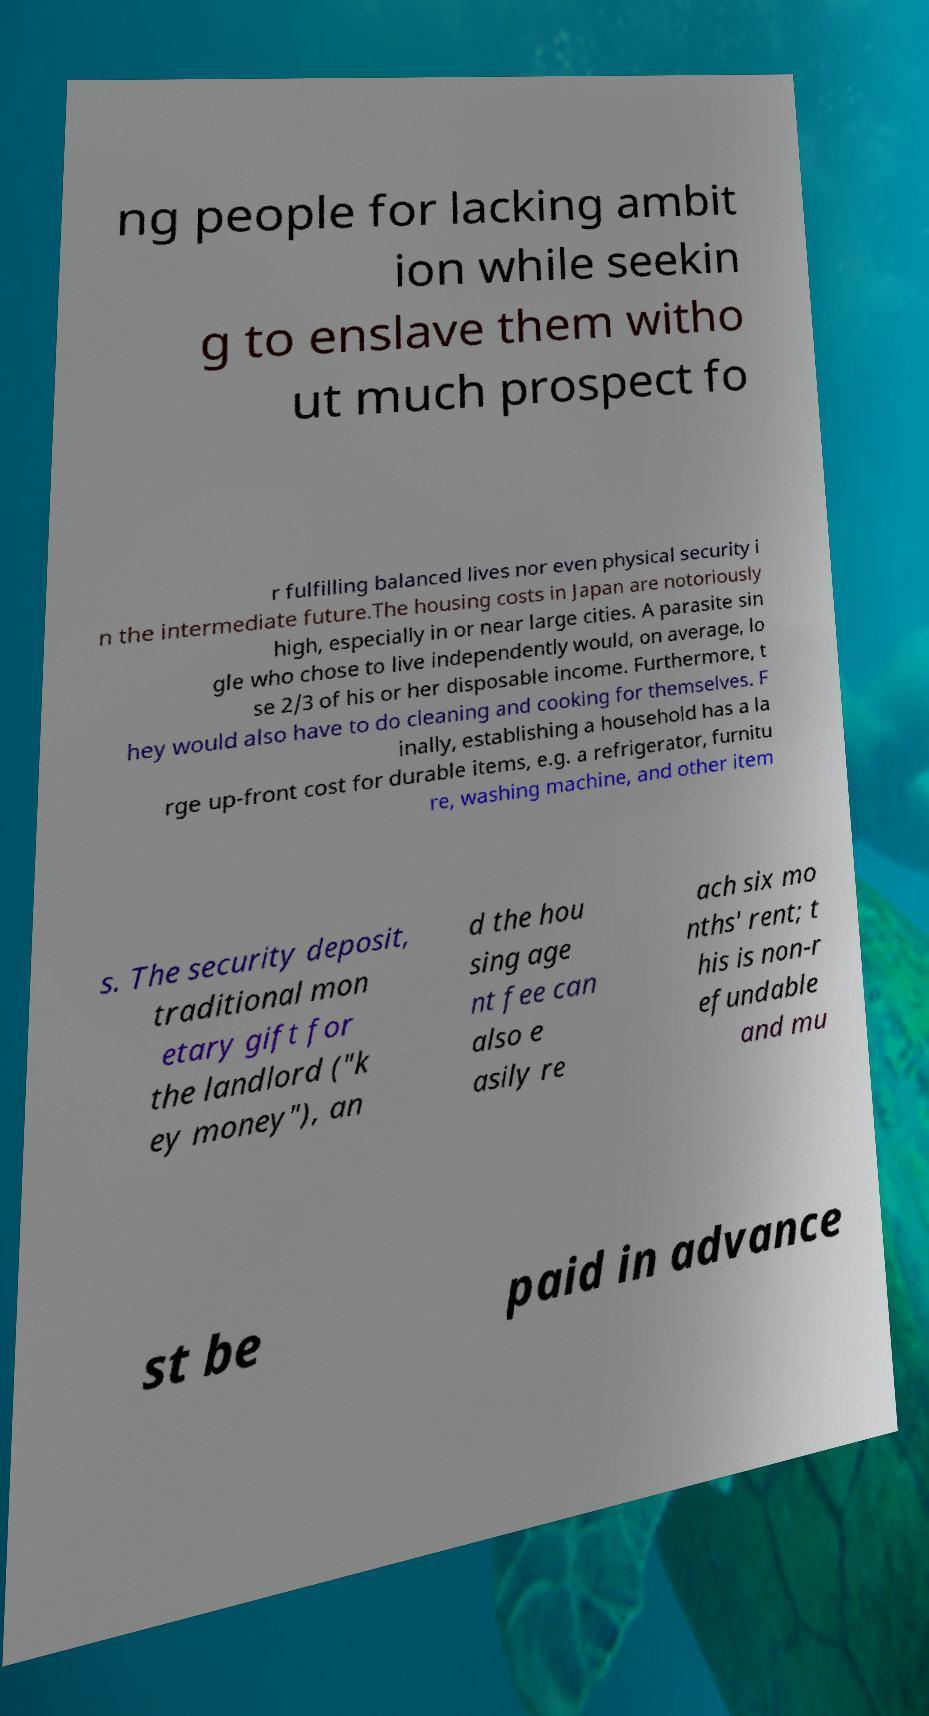There's text embedded in this image that I need extracted. Can you transcribe it verbatim? ng people for lacking ambit ion while seekin g to enslave them witho ut much prospect fo r fulfilling balanced lives nor even physical security i n the intermediate future.The housing costs in Japan are notoriously high, especially in or near large cities. A parasite sin gle who chose to live independently would, on average, lo se 2/3 of his or her disposable income. Furthermore, t hey would also have to do cleaning and cooking for themselves. F inally, establishing a household has a la rge up-front cost for durable items, e.g. a refrigerator, furnitu re, washing machine, and other item s. The security deposit, traditional mon etary gift for the landlord ("k ey money"), an d the hou sing age nt fee can also e asily re ach six mo nths' rent; t his is non-r efundable and mu st be paid in advance 